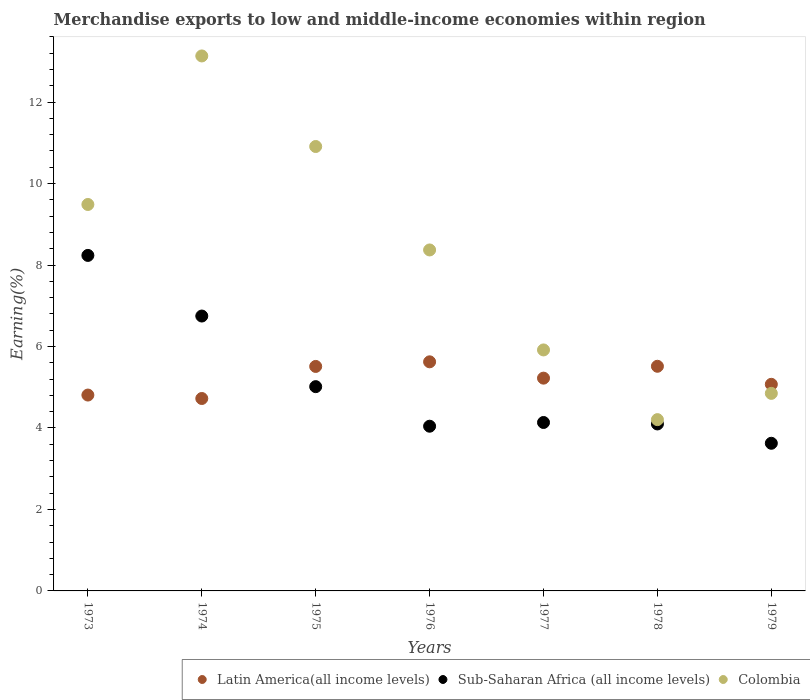What is the percentage of amount earned from merchandise exports in Sub-Saharan Africa (all income levels) in 1973?
Give a very brief answer. 8.24. Across all years, what is the maximum percentage of amount earned from merchandise exports in Latin America(all income levels)?
Your answer should be compact. 5.62. Across all years, what is the minimum percentage of amount earned from merchandise exports in Sub-Saharan Africa (all income levels)?
Your answer should be very brief. 3.62. In which year was the percentage of amount earned from merchandise exports in Colombia maximum?
Ensure brevity in your answer.  1974. In which year was the percentage of amount earned from merchandise exports in Colombia minimum?
Provide a succinct answer. 1978. What is the total percentage of amount earned from merchandise exports in Sub-Saharan Africa (all income levels) in the graph?
Provide a succinct answer. 35.9. What is the difference between the percentage of amount earned from merchandise exports in Sub-Saharan Africa (all income levels) in 1973 and that in 1975?
Offer a terse response. 3.22. What is the difference between the percentage of amount earned from merchandise exports in Sub-Saharan Africa (all income levels) in 1979 and the percentage of amount earned from merchandise exports in Latin America(all income levels) in 1975?
Offer a terse response. -1.89. What is the average percentage of amount earned from merchandise exports in Colombia per year?
Give a very brief answer. 8.12. In the year 1973, what is the difference between the percentage of amount earned from merchandise exports in Sub-Saharan Africa (all income levels) and percentage of amount earned from merchandise exports in Latin America(all income levels)?
Your response must be concise. 3.43. What is the ratio of the percentage of amount earned from merchandise exports in Latin America(all income levels) in 1976 to that in 1977?
Your answer should be compact. 1.08. Is the percentage of amount earned from merchandise exports in Colombia in 1973 less than that in 1977?
Offer a very short reply. No. Is the difference between the percentage of amount earned from merchandise exports in Sub-Saharan Africa (all income levels) in 1975 and 1978 greater than the difference between the percentage of amount earned from merchandise exports in Latin America(all income levels) in 1975 and 1978?
Make the answer very short. Yes. What is the difference between the highest and the second highest percentage of amount earned from merchandise exports in Latin America(all income levels)?
Offer a very short reply. 0.11. What is the difference between the highest and the lowest percentage of amount earned from merchandise exports in Latin America(all income levels)?
Your answer should be very brief. 0.9. Is the sum of the percentage of amount earned from merchandise exports in Latin America(all income levels) in 1973 and 1978 greater than the maximum percentage of amount earned from merchandise exports in Colombia across all years?
Your response must be concise. No. Does the percentage of amount earned from merchandise exports in Latin America(all income levels) monotonically increase over the years?
Offer a very short reply. No. Is the percentage of amount earned from merchandise exports in Sub-Saharan Africa (all income levels) strictly greater than the percentage of amount earned from merchandise exports in Latin America(all income levels) over the years?
Ensure brevity in your answer.  No. How many dotlines are there?
Your answer should be compact. 3. What is the title of the graph?
Keep it short and to the point. Merchandise exports to low and middle-income economies within region. Does "Italy" appear as one of the legend labels in the graph?
Your response must be concise. No. What is the label or title of the X-axis?
Provide a succinct answer. Years. What is the label or title of the Y-axis?
Make the answer very short. Earning(%). What is the Earning(%) of Latin America(all income levels) in 1973?
Make the answer very short. 4.81. What is the Earning(%) of Sub-Saharan Africa (all income levels) in 1973?
Offer a very short reply. 8.24. What is the Earning(%) of Colombia in 1973?
Your answer should be very brief. 9.49. What is the Earning(%) of Latin America(all income levels) in 1974?
Provide a succinct answer. 4.72. What is the Earning(%) of Sub-Saharan Africa (all income levels) in 1974?
Offer a very short reply. 6.75. What is the Earning(%) of Colombia in 1974?
Provide a succinct answer. 13.13. What is the Earning(%) of Latin America(all income levels) in 1975?
Your answer should be very brief. 5.51. What is the Earning(%) of Sub-Saharan Africa (all income levels) in 1975?
Keep it short and to the point. 5.01. What is the Earning(%) in Colombia in 1975?
Your answer should be compact. 10.91. What is the Earning(%) of Latin America(all income levels) in 1976?
Ensure brevity in your answer.  5.62. What is the Earning(%) of Sub-Saharan Africa (all income levels) in 1976?
Give a very brief answer. 4.04. What is the Earning(%) of Colombia in 1976?
Offer a very short reply. 8.37. What is the Earning(%) of Latin America(all income levels) in 1977?
Ensure brevity in your answer.  5.22. What is the Earning(%) in Sub-Saharan Africa (all income levels) in 1977?
Keep it short and to the point. 4.13. What is the Earning(%) in Colombia in 1977?
Give a very brief answer. 5.92. What is the Earning(%) of Latin America(all income levels) in 1978?
Keep it short and to the point. 5.51. What is the Earning(%) in Sub-Saharan Africa (all income levels) in 1978?
Your response must be concise. 4.1. What is the Earning(%) in Colombia in 1978?
Keep it short and to the point. 4.2. What is the Earning(%) in Latin America(all income levels) in 1979?
Give a very brief answer. 5.07. What is the Earning(%) in Sub-Saharan Africa (all income levels) in 1979?
Make the answer very short. 3.62. What is the Earning(%) of Colombia in 1979?
Your response must be concise. 4.85. Across all years, what is the maximum Earning(%) of Latin America(all income levels)?
Ensure brevity in your answer.  5.62. Across all years, what is the maximum Earning(%) in Sub-Saharan Africa (all income levels)?
Keep it short and to the point. 8.24. Across all years, what is the maximum Earning(%) of Colombia?
Your answer should be very brief. 13.13. Across all years, what is the minimum Earning(%) of Latin America(all income levels)?
Your answer should be compact. 4.72. Across all years, what is the minimum Earning(%) of Sub-Saharan Africa (all income levels)?
Offer a very short reply. 3.62. Across all years, what is the minimum Earning(%) of Colombia?
Make the answer very short. 4.2. What is the total Earning(%) in Latin America(all income levels) in the graph?
Your answer should be compact. 36.47. What is the total Earning(%) of Sub-Saharan Africa (all income levels) in the graph?
Offer a very short reply. 35.9. What is the total Earning(%) of Colombia in the graph?
Make the answer very short. 56.87. What is the difference between the Earning(%) in Latin America(all income levels) in 1973 and that in 1974?
Your answer should be very brief. 0.08. What is the difference between the Earning(%) of Sub-Saharan Africa (all income levels) in 1973 and that in 1974?
Offer a very short reply. 1.49. What is the difference between the Earning(%) of Colombia in 1973 and that in 1974?
Offer a terse response. -3.65. What is the difference between the Earning(%) in Latin America(all income levels) in 1973 and that in 1975?
Your response must be concise. -0.7. What is the difference between the Earning(%) in Sub-Saharan Africa (all income levels) in 1973 and that in 1975?
Keep it short and to the point. 3.22. What is the difference between the Earning(%) in Colombia in 1973 and that in 1975?
Keep it short and to the point. -1.42. What is the difference between the Earning(%) in Latin America(all income levels) in 1973 and that in 1976?
Provide a succinct answer. -0.82. What is the difference between the Earning(%) of Sub-Saharan Africa (all income levels) in 1973 and that in 1976?
Offer a terse response. 4.19. What is the difference between the Earning(%) of Colombia in 1973 and that in 1976?
Ensure brevity in your answer.  1.12. What is the difference between the Earning(%) in Latin America(all income levels) in 1973 and that in 1977?
Your response must be concise. -0.41. What is the difference between the Earning(%) of Sub-Saharan Africa (all income levels) in 1973 and that in 1977?
Your answer should be very brief. 4.1. What is the difference between the Earning(%) of Colombia in 1973 and that in 1977?
Keep it short and to the point. 3.57. What is the difference between the Earning(%) in Latin America(all income levels) in 1973 and that in 1978?
Give a very brief answer. -0.71. What is the difference between the Earning(%) in Sub-Saharan Africa (all income levels) in 1973 and that in 1978?
Your answer should be compact. 4.14. What is the difference between the Earning(%) in Colombia in 1973 and that in 1978?
Your answer should be compact. 5.28. What is the difference between the Earning(%) of Latin America(all income levels) in 1973 and that in 1979?
Offer a very short reply. -0.26. What is the difference between the Earning(%) in Sub-Saharan Africa (all income levels) in 1973 and that in 1979?
Make the answer very short. 4.61. What is the difference between the Earning(%) in Colombia in 1973 and that in 1979?
Offer a very short reply. 4.64. What is the difference between the Earning(%) in Latin America(all income levels) in 1974 and that in 1975?
Make the answer very short. -0.79. What is the difference between the Earning(%) in Sub-Saharan Africa (all income levels) in 1974 and that in 1975?
Keep it short and to the point. 1.73. What is the difference between the Earning(%) of Colombia in 1974 and that in 1975?
Your answer should be compact. 2.22. What is the difference between the Earning(%) in Latin America(all income levels) in 1974 and that in 1976?
Ensure brevity in your answer.  -0.9. What is the difference between the Earning(%) in Sub-Saharan Africa (all income levels) in 1974 and that in 1976?
Keep it short and to the point. 2.7. What is the difference between the Earning(%) in Colombia in 1974 and that in 1976?
Give a very brief answer. 4.76. What is the difference between the Earning(%) of Latin America(all income levels) in 1974 and that in 1977?
Your answer should be very brief. -0.5. What is the difference between the Earning(%) in Sub-Saharan Africa (all income levels) in 1974 and that in 1977?
Provide a succinct answer. 2.61. What is the difference between the Earning(%) in Colombia in 1974 and that in 1977?
Make the answer very short. 7.22. What is the difference between the Earning(%) in Latin America(all income levels) in 1974 and that in 1978?
Offer a very short reply. -0.79. What is the difference between the Earning(%) of Sub-Saharan Africa (all income levels) in 1974 and that in 1978?
Provide a succinct answer. 2.65. What is the difference between the Earning(%) in Colombia in 1974 and that in 1978?
Your response must be concise. 8.93. What is the difference between the Earning(%) of Latin America(all income levels) in 1974 and that in 1979?
Keep it short and to the point. -0.35. What is the difference between the Earning(%) in Sub-Saharan Africa (all income levels) in 1974 and that in 1979?
Ensure brevity in your answer.  3.12. What is the difference between the Earning(%) of Colombia in 1974 and that in 1979?
Provide a succinct answer. 8.28. What is the difference between the Earning(%) in Latin America(all income levels) in 1975 and that in 1976?
Make the answer very short. -0.11. What is the difference between the Earning(%) in Sub-Saharan Africa (all income levels) in 1975 and that in 1976?
Provide a short and direct response. 0.97. What is the difference between the Earning(%) in Colombia in 1975 and that in 1976?
Provide a short and direct response. 2.54. What is the difference between the Earning(%) of Latin America(all income levels) in 1975 and that in 1977?
Provide a succinct answer. 0.29. What is the difference between the Earning(%) in Sub-Saharan Africa (all income levels) in 1975 and that in 1977?
Keep it short and to the point. 0.88. What is the difference between the Earning(%) of Colombia in 1975 and that in 1977?
Your answer should be very brief. 4.99. What is the difference between the Earning(%) of Latin America(all income levels) in 1975 and that in 1978?
Give a very brief answer. -0. What is the difference between the Earning(%) of Sub-Saharan Africa (all income levels) in 1975 and that in 1978?
Offer a terse response. 0.92. What is the difference between the Earning(%) of Colombia in 1975 and that in 1978?
Provide a short and direct response. 6.7. What is the difference between the Earning(%) of Latin America(all income levels) in 1975 and that in 1979?
Your answer should be compact. 0.44. What is the difference between the Earning(%) in Sub-Saharan Africa (all income levels) in 1975 and that in 1979?
Make the answer very short. 1.39. What is the difference between the Earning(%) in Colombia in 1975 and that in 1979?
Your answer should be very brief. 6.06. What is the difference between the Earning(%) in Latin America(all income levels) in 1976 and that in 1977?
Your response must be concise. 0.4. What is the difference between the Earning(%) in Sub-Saharan Africa (all income levels) in 1976 and that in 1977?
Your answer should be compact. -0.09. What is the difference between the Earning(%) in Colombia in 1976 and that in 1977?
Your answer should be very brief. 2.45. What is the difference between the Earning(%) in Latin America(all income levels) in 1976 and that in 1978?
Offer a very short reply. 0.11. What is the difference between the Earning(%) in Sub-Saharan Africa (all income levels) in 1976 and that in 1978?
Make the answer very short. -0.06. What is the difference between the Earning(%) of Colombia in 1976 and that in 1978?
Offer a terse response. 4.17. What is the difference between the Earning(%) of Latin America(all income levels) in 1976 and that in 1979?
Your answer should be compact. 0.55. What is the difference between the Earning(%) in Sub-Saharan Africa (all income levels) in 1976 and that in 1979?
Make the answer very short. 0.42. What is the difference between the Earning(%) of Colombia in 1976 and that in 1979?
Provide a short and direct response. 3.52. What is the difference between the Earning(%) in Latin America(all income levels) in 1977 and that in 1978?
Offer a terse response. -0.29. What is the difference between the Earning(%) in Sub-Saharan Africa (all income levels) in 1977 and that in 1978?
Provide a succinct answer. 0.04. What is the difference between the Earning(%) in Colombia in 1977 and that in 1978?
Provide a short and direct response. 1.71. What is the difference between the Earning(%) in Latin America(all income levels) in 1977 and that in 1979?
Give a very brief answer. 0.15. What is the difference between the Earning(%) of Sub-Saharan Africa (all income levels) in 1977 and that in 1979?
Your answer should be compact. 0.51. What is the difference between the Earning(%) of Colombia in 1977 and that in 1979?
Your answer should be compact. 1.07. What is the difference between the Earning(%) in Latin America(all income levels) in 1978 and that in 1979?
Provide a short and direct response. 0.44. What is the difference between the Earning(%) in Sub-Saharan Africa (all income levels) in 1978 and that in 1979?
Give a very brief answer. 0.47. What is the difference between the Earning(%) in Colombia in 1978 and that in 1979?
Your answer should be very brief. -0.64. What is the difference between the Earning(%) of Latin America(all income levels) in 1973 and the Earning(%) of Sub-Saharan Africa (all income levels) in 1974?
Provide a short and direct response. -1.94. What is the difference between the Earning(%) of Latin America(all income levels) in 1973 and the Earning(%) of Colombia in 1974?
Your answer should be compact. -8.32. What is the difference between the Earning(%) in Sub-Saharan Africa (all income levels) in 1973 and the Earning(%) in Colombia in 1974?
Give a very brief answer. -4.9. What is the difference between the Earning(%) of Latin America(all income levels) in 1973 and the Earning(%) of Sub-Saharan Africa (all income levels) in 1975?
Offer a very short reply. -0.21. What is the difference between the Earning(%) of Latin America(all income levels) in 1973 and the Earning(%) of Colombia in 1975?
Ensure brevity in your answer.  -6.1. What is the difference between the Earning(%) of Sub-Saharan Africa (all income levels) in 1973 and the Earning(%) of Colombia in 1975?
Provide a short and direct response. -2.67. What is the difference between the Earning(%) in Latin America(all income levels) in 1973 and the Earning(%) in Sub-Saharan Africa (all income levels) in 1976?
Make the answer very short. 0.77. What is the difference between the Earning(%) of Latin America(all income levels) in 1973 and the Earning(%) of Colombia in 1976?
Offer a terse response. -3.56. What is the difference between the Earning(%) of Sub-Saharan Africa (all income levels) in 1973 and the Earning(%) of Colombia in 1976?
Your response must be concise. -0.13. What is the difference between the Earning(%) of Latin America(all income levels) in 1973 and the Earning(%) of Sub-Saharan Africa (all income levels) in 1977?
Your answer should be very brief. 0.67. What is the difference between the Earning(%) in Latin America(all income levels) in 1973 and the Earning(%) in Colombia in 1977?
Give a very brief answer. -1.11. What is the difference between the Earning(%) of Sub-Saharan Africa (all income levels) in 1973 and the Earning(%) of Colombia in 1977?
Keep it short and to the point. 2.32. What is the difference between the Earning(%) in Latin America(all income levels) in 1973 and the Earning(%) in Sub-Saharan Africa (all income levels) in 1978?
Your answer should be very brief. 0.71. What is the difference between the Earning(%) of Latin America(all income levels) in 1973 and the Earning(%) of Colombia in 1978?
Keep it short and to the point. 0.6. What is the difference between the Earning(%) of Sub-Saharan Africa (all income levels) in 1973 and the Earning(%) of Colombia in 1978?
Make the answer very short. 4.03. What is the difference between the Earning(%) in Latin America(all income levels) in 1973 and the Earning(%) in Sub-Saharan Africa (all income levels) in 1979?
Give a very brief answer. 1.18. What is the difference between the Earning(%) in Latin America(all income levels) in 1973 and the Earning(%) in Colombia in 1979?
Offer a very short reply. -0.04. What is the difference between the Earning(%) in Sub-Saharan Africa (all income levels) in 1973 and the Earning(%) in Colombia in 1979?
Your response must be concise. 3.39. What is the difference between the Earning(%) in Latin America(all income levels) in 1974 and the Earning(%) in Sub-Saharan Africa (all income levels) in 1975?
Provide a short and direct response. -0.29. What is the difference between the Earning(%) of Latin America(all income levels) in 1974 and the Earning(%) of Colombia in 1975?
Your answer should be very brief. -6.19. What is the difference between the Earning(%) of Sub-Saharan Africa (all income levels) in 1974 and the Earning(%) of Colombia in 1975?
Offer a very short reply. -4.16. What is the difference between the Earning(%) of Latin America(all income levels) in 1974 and the Earning(%) of Sub-Saharan Africa (all income levels) in 1976?
Your response must be concise. 0.68. What is the difference between the Earning(%) of Latin America(all income levels) in 1974 and the Earning(%) of Colombia in 1976?
Ensure brevity in your answer.  -3.65. What is the difference between the Earning(%) in Sub-Saharan Africa (all income levels) in 1974 and the Earning(%) in Colombia in 1976?
Your answer should be very brief. -1.62. What is the difference between the Earning(%) of Latin America(all income levels) in 1974 and the Earning(%) of Sub-Saharan Africa (all income levels) in 1977?
Make the answer very short. 0.59. What is the difference between the Earning(%) of Latin America(all income levels) in 1974 and the Earning(%) of Colombia in 1977?
Ensure brevity in your answer.  -1.19. What is the difference between the Earning(%) in Sub-Saharan Africa (all income levels) in 1974 and the Earning(%) in Colombia in 1977?
Provide a short and direct response. 0.83. What is the difference between the Earning(%) in Latin America(all income levels) in 1974 and the Earning(%) in Sub-Saharan Africa (all income levels) in 1978?
Provide a short and direct response. 0.62. What is the difference between the Earning(%) of Latin America(all income levels) in 1974 and the Earning(%) of Colombia in 1978?
Provide a succinct answer. 0.52. What is the difference between the Earning(%) in Sub-Saharan Africa (all income levels) in 1974 and the Earning(%) in Colombia in 1978?
Ensure brevity in your answer.  2.54. What is the difference between the Earning(%) of Latin America(all income levels) in 1974 and the Earning(%) of Sub-Saharan Africa (all income levels) in 1979?
Your answer should be very brief. 1.1. What is the difference between the Earning(%) of Latin America(all income levels) in 1974 and the Earning(%) of Colombia in 1979?
Your answer should be compact. -0.13. What is the difference between the Earning(%) in Sub-Saharan Africa (all income levels) in 1974 and the Earning(%) in Colombia in 1979?
Ensure brevity in your answer.  1.9. What is the difference between the Earning(%) in Latin America(all income levels) in 1975 and the Earning(%) in Sub-Saharan Africa (all income levels) in 1976?
Offer a terse response. 1.47. What is the difference between the Earning(%) of Latin America(all income levels) in 1975 and the Earning(%) of Colombia in 1976?
Give a very brief answer. -2.86. What is the difference between the Earning(%) in Sub-Saharan Africa (all income levels) in 1975 and the Earning(%) in Colombia in 1976?
Keep it short and to the point. -3.36. What is the difference between the Earning(%) in Latin America(all income levels) in 1975 and the Earning(%) in Sub-Saharan Africa (all income levels) in 1977?
Provide a succinct answer. 1.38. What is the difference between the Earning(%) of Latin America(all income levels) in 1975 and the Earning(%) of Colombia in 1977?
Give a very brief answer. -0.41. What is the difference between the Earning(%) in Sub-Saharan Africa (all income levels) in 1975 and the Earning(%) in Colombia in 1977?
Your answer should be very brief. -0.9. What is the difference between the Earning(%) in Latin America(all income levels) in 1975 and the Earning(%) in Sub-Saharan Africa (all income levels) in 1978?
Your response must be concise. 1.41. What is the difference between the Earning(%) in Latin America(all income levels) in 1975 and the Earning(%) in Colombia in 1978?
Make the answer very short. 1.31. What is the difference between the Earning(%) of Sub-Saharan Africa (all income levels) in 1975 and the Earning(%) of Colombia in 1978?
Your response must be concise. 0.81. What is the difference between the Earning(%) of Latin America(all income levels) in 1975 and the Earning(%) of Sub-Saharan Africa (all income levels) in 1979?
Provide a succinct answer. 1.89. What is the difference between the Earning(%) of Latin America(all income levels) in 1975 and the Earning(%) of Colombia in 1979?
Keep it short and to the point. 0.66. What is the difference between the Earning(%) in Sub-Saharan Africa (all income levels) in 1975 and the Earning(%) in Colombia in 1979?
Provide a short and direct response. 0.17. What is the difference between the Earning(%) in Latin America(all income levels) in 1976 and the Earning(%) in Sub-Saharan Africa (all income levels) in 1977?
Give a very brief answer. 1.49. What is the difference between the Earning(%) of Latin America(all income levels) in 1976 and the Earning(%) of Colombia in 1977?
Your response must be concise. -0.29. What is the difference between the Earning(%) of Sub-Saharan Africa (all income levels) in 1976 and the Earning(%) of Colombia in 1977?
Your answer should be compact. -1.87. What is the difference between the Earning(%) of Latin America(all income levels) in 1976 and the Earning(%) of Sub-Saharan Africa (all income levels) in 1978?
Your answer should be very brief. 1.52. What is the difference between the Earning(%) in Latin America(all income levels) in 1976 and the Earning(%) in Colombia in 1978?
Make the answer very short. 1.42. What is the difference between the Earning(%) of Sub-Saharan Africa (all income levels) in 1976 and the Earning(%) of Colombia in 1978?
Give a very brief answer. -0.16. What is the difference between the Earning(%) in Latin America(all income levels) in 1976 and the Earning(%) in Sub-Saharan Africa (all income levels) in 1979?
Your answer should be very brief. 2. What is the difference between the Earning(%) in Latin America(all income levels) in 1976 and the Earning(%) in Colombia in 1979?
Provide a succinct answer. 0.77. What is the difference between the Earning(%) in Sub-Saharan Africa (all income levels) in 1976 and the Earning(%) in Colombia in 1979?
Offer a very short reply. -0.81. What is the difference between the Earning(%) in Latin America(all income levels) in 1977 and the Earning(%) in Sub-Saharan Africa (all income levels) in 1978?
Make the answer very short. 1.12. What is the difference between the Earning(%) in Latin America(all income levels) in 1977 and the Earning(%) in Colombia in 1978?
Provide a short and direct response. 1.02. What is the difference between the Earning(%) in Sub-Saharan Africa (all income levels) in 1977 and the Earning(%) in Colombia in 1978?
Your answer should be very brief. -0.07. What is the difference between the Earning(%) of Latin America(all income levels) in 1977 and the Earning(%) of Sub-Saharan Africa (all income levels) in 1979?
Provide a short and direct response. 1.6. What is the difference between the Earning(%) in Latin America(all income levels) in 1977 and the Earning(%) in Colombia in 1979?
Provide a succinct answer. 0.37. What is the difference between the Earning(%) of Sub-Saharan Africa (all income levels) in 1977 and the Earning(%) of Colombia in 1979?
Provide a short and direct response. -0.71. What is the difference between the Earning(%) of Latin America(all income levels) in 1978 and the Earning(%) of Sub-Saharan Africa (all income levels) in 1979?
Provide a short and direct response. 1.89. What is the difference between the Earning(%) in Latin America(all income levels) in 1978 and the Earning(%) in Colombia in 1979?
Provide a short and direct response. 0.67. What is the difference between the Earning(%) of Sub-Saharan Africa (all income levels) in 1978 and the Earning(%) of Colombia in 1979?
Provide a short and direct response. -0.75. What is the average Earning(%) of Latin America(all income levels) per year?
Provide a succinct answer. 5.21. What is the average Earning(%) of Sub-Saharan Africa (all income levels) per year?
Provide a succinct answer. 5.13. What is the average Earning(%) in Colombia per year?
Provide a short and direct response. 8.12. In the year 1973, what is the difference between the Earning(%) of Latin America(all income levels) and Earning(%) of Sub-Saharan Africa (all income levels)?
Keep it short and to the point. -3.43. In the year 1973, what is the difference between the Earning(%) in Latin America(all income levels) and Earning(%) in Colombia?
Your answer should be very brief. -4.68. In the year 1973, what is the difference between the Earning(%) in Sub-Saharan Africa (all income levels) and Earning(%) in Colombia?
Your answer should be very brief. -1.25. In the year 1974, what is the difference between the Earning(%) of Latin America(all income levels) and Earning(%) of Sub-Saharan Africa (all income levels)?
Offer a very short reply. -2.02. In the year 1974, what is the difference between the Earning(%) of Latin America(all income levels) and Earning(%) of Colombia?
Offer a terse response. -8.41. In the year 1974, what is the difference between the Earning(%) in Sub-Saharan Africa (all income levels) and Earning(%) in Colombia?
Provide a succinct answer. -6.38. In the year 1975, what is the difference between the Earning(%) of Latin America(all income levels) and Earning(%) of Sub-Saharan Africa (all income levels)?
Provide a succinct answer. 0.5. In the year 1975, what is the difference between the Earning(%) in Latin America(all income levels) and Earning(%) in Colombia?
Your response must be concise. -5.4. In the year 1975, what is the difference between the Earning(%) of Sub-Saharan Africa (all income levels) and Earning(%) of Colombia?
Provide a succinct answer. -5.89. In the year 1976, what is the difference between the Earning(%) of Latin America(all income levels) and Earning(%) of Sub-Saharan Africa (all income levels)?
Provide a short and direct response. 1.58. In the year 1976, what is the difference between the Earning(%) of Latin America(all income levels) and Earning(%) of Colombia?
Ensure brevity in your answer.  -2.75. In the year 1976, what is the difference between the Earning(%) of Sub-Saharan Africa (all income levels) and Earning(%) of Colombia?
Provide a short and direct response. -4.33. In the year 1977, what is the difference between the Earning(%) in Latin America(all income levels) and Earning(%) in Sub-Saharan Africa (all income levels)?
Make the answer very short. 1.09. In the year 1977, what is the difference between the Earning(%) in Latin America(all income levels) and Earning(%) in Colombia?
Provide a short and direct response. -0.69. In the year 1977, what is the difference between the Earning(%) of Sub-Saharan Africa (all income levels) and Earning(%) of Colombia?
Provide a succinct answer. -1.78. In the year 1978, what is the difference between the Earning(%) of Latin America(all income levels) and Earning(%) of Sub-Saharan Africa (all income levels)?
Provide a succinct answer. 1.42. In the year 1978, what is the difference between the Earning(%) in Latin America(all income levels) and Earning(%) in Colombia?
Make the answer very short. 1.31. In the year 1978, what is the difference between the Earning(%) in Sub-Saharan Africa (all income levels) and Earning(%) in Colombia?
Provide a succinct answer. -0.11. In the year 1979, what is the difference between the Earning(%) of Latin America(all income levels) and Earning(%) of Sub-Saharan Africa (all income levels)?
Provide a succinct answer. 1.45. In the year 1979, what is the difference between the Earning(%) of Latin America(all income levels) and Earning(%) of Colombia?
Your response must be concise. 0.22. In the year 1979, what is the difference between the Earning(%) of Sub-Saharan Africa (all income levels) and Earning(%) of Colombia?
Provide a succinct answer. -1.23. What is the ratio of the Earning(%) of Latin America(all income levels) in 1973 to that in 1974?
Offer a very short reply. 1.02. What is the ratio of the Earning(%) in Sub-Saharan Africa (all income levels) in 1973 to that in 1974?
Keep it short and to the point. 1.22. What is the ratio of the Earning(%) in Colombia in 1973 to that in 1974?
Give a very brief answer. 0.72. What is the ratio of the Earning(%) in Latin America(all income levels) in 1973 to that in 1975?
Offer a terse response. 0.87. What is the ratio of the Earning(%) in Sub-Saharan Africa (all income levels) in 1973 to that in 1975?
Your answer should be compact. 1.64. What is the ratio of the Earning(%) in Colombia in 1973 to that in 1975?
Keep it short and to the point. 0.87. What is the ratio of the Earning(%) of Latin America(all income levels) in 1973 to that in 1976?
Provide a short and direct response. 0.85. What is the ratio of the Earning(%) in Sub-Saharan Africa (all income levels) in 1973 to that in 1976?
Your answer should be very brief. 2.04. What is the ratio of the Earning(%) in Colombia in 1973 to that in 1976?
Offer a terse response. 1.13. What is the ratio of the Earning(%) of Latin America(all income levels) in 1973 to that in 1977?
Give a very brief answer. 0.92. What is the ratio of the Earning(%) in Sub-Saharan Africa (all income levels) in 1973 to that in 1977?
Give a very brief answer. 1.99. What is the ratio of the Earning(%) of Colombia in 1973 to that in 1977?
Make the answer very short. 1.6. What is the ratio of the Earning(%) of Latin America(all income levels) in 1973 to that in 1978?
Your response must be concise. 0.87. What is the ratio of the Earning(%) of Sub-Saharan Africa (all income levels) in 1973 to that in 1978?
Your answer should be compact. 2.01. What is the ratio of the Earning(%) in Colombia in 1973 to that in 1978?
Offer a terse response. 2.26. What is the ratio of the Earning(%) of Latin America(all income levels) in 1973 to that in 1979?
Your answer should be very brief. 0.95. What is the ratio of the Earning(%) of Sub-Saharan Africa (all income levels) in 1973 to that in 1979?
Make the answer very short. 2.27. What is the ratio of the Earning(%) of Colombia in 1973 to that in 1979?
Offer a very short reply. 1.96. What is the ratio of the Earning(%) of Latin America(all income levels) in 1974 to that in 1975?
Offer a terse response. 0.86. What is the ratio of the Earning(%) of Sub-Saharan Africa (all income levels) in 1974 to that in 1975?
Provide a short and direct response. 1.35. What is the ratio of the Earning(%) of Colombia in 1974 to that in 1975?
Ensure brevity in your answer.  1.2. What is the ratio of the Earning(%) of Latin America(all income levels) in 1974 to that in 1976?
Provide a short and direct response. 0.84. What is the ratio of the Earning(%) in Sub-Saharan Africa (all income levels) in 1974 to that in 1976?
Offer a terse response. 1.67. What is the ratio of the Earning(%) of Colombia in 1974 to that in 1976?
Provide a succinct answer. 1.57. What is the ratio of the Earning(%) in Latin America(all income levels) in 1974 to that in 1977?
Make the answer very short. 0.9. What is the ratio of the Earning(%) of Sub-Saharan Africa (all income levels) in 1974 to that in 1977?
Your answer should be very brief. 1.63. What is the ratio of the Earning(%) in Colombia in 1974 to that in 1977?
Ensure brevity in your answer.  2.22. What is the ratio of the Earning(%) of Latin America(all income levels) in 1974 to that in 1978?
Provide a short and direct response. 0.86. What is the ratio of the Earning(%) of Sub-Saharan Africa (all income levels) in 1974 to that in 1978?
Keep it short and to the point. 1.65. What is the ratio of the Earning(%) in Colombia in 1974 to that in 1978?
Keep it short and to the point. 3.12. What is the ratio of the Earning(%) of Latin America(all income levels) in 1974 to that in 1979?
Offer a terse response. 0.93. What is the ratio of the Earning(%) of Sub-Saharan Africa (all income levels) in 1974 to that in 1979?
Provide a succinct answer. 1.86. What is the ratio of the Earning(%) in Colombia in 1974 to that in 1979?
Your answer should be compact. 2.71. What is the ratio of the Earning(%) of Latin America(all income levels) in 1975 to that in 1976?
Provide a succinct answer. 0.98. What is the ratio of the Earning(%) of Sub-Saharan Africa (all income levels) in 1975 to that in 1976?
Offer a terse response. 1.24. What is the ratio of the Earning(%) of Colombia in 1975 to that in 1976?
Provide a short and direct response. 1.3. What is the ratio of the Earning(%) in Latin America(all income levels) in 1975 to that in 1977?
Your answer should be compact. 1.05. What is the ratio of the Earning(%) in Sub-Saharan Africa (all income levels) in 1975 to that in 1977?
Offer a terse response. 1.21. What is the ratio of the Earning(%) of Colombia in 1975 to that in 1977?
Offer a terse response. 1.84. What is the ratio of the Earning(%) in Sub-Saharan Africa (all income levels) in 1975 to that in 1978?
Provide a succinct answer. 1.22. What is the ratio of the Earning(%) of Colombia in 1975 to that in 1978?
Provide a short and direct response. 2.59. What is the ratio of the Earning(%) of Latin America(all income levels) in 1975 to that in 1979?
Make the answer very short. 1.09. What is the ratio of the Earning(%) of Sub-Saharan Africa (all income levels) in 1975 to that in 1979?
Provide a short and direct response. 1.38. What is the ratio of the Earning(%) of Colombia in 1975 to that in 1979?
Ensure brevity in your answer.  2.25. What is the ratio of the Earning(%) of Latin America(all income levels) in 1976 to that in 1977?
Ensure brevity in your answer.  1.08. What is the ratio of the Earning(%) of Sub-Saharan Africa (all income levels) in 1976 to that in 1977?
Your response must be concise. 0.98. What is the ratio of the Earning(%) of Colombia in 1976 to that in 1977?
Offer a very short reply. 1.41. What is the ratio of the Earning(%) of Latin America(all income levels) in 1976 to that in 1978?
Your answer should be very brief. 1.02. What is the ratio of the Earning(%) of Sub-Saharan Africa (all income levels) in 1976 to that in 1978?
Your answer should be very brief. 0.99. What is the ratio of the Earning(%) in Colombia in 1976 to that in 1978?
Provide a succinct answer. 1.99. What is the ratio of the Earning(%) in Latin America(all income levels) in 1976 to that in 1979?
Offer a terse response. 1.11. What is the ratio of the Earning(%) in Sub-Saharan Africa (all income levels) in 1976 to that in 1979?
Your answer should be very brief. 1.12. What is the ratio of the Earning(%) of Colombia in 1976 to that in 1979?
Your response must be concise. 1.73. What is the ratio of the Earning(%) of Latin America(all income levels) in 1977 to that in 1978?
Your answer should be very brief. 0.95. What is the ratio of the Earning(%) in Sub-Saharan Africa (all income levels) in 1977 to that in 1978?
Make the answer very short. 1.01. What is the ratio of the Earning(%) of Colombia in 1977 to that in 1978?
Keep it short and to the point. 1.41. What is the ratio of the Earning(%) of Latin America(all income levels) in 1977 to that in 1979?
Provide a succinct answer. 1.03. What is the ratio of the Earning(%) of Sub-Saharan Africa (all income levels) in 1977 to that in 1979?
Keep it short and to the point. 1.14. What is the ratio of the Earning(%) of Colombia in 1977 to that in 1979?
Your answer should be compact. 1.22. What is the ratio of the Earning(%) in Latin America(all income levels) in 1978 to that in 1979?
Keep it short and to the point. 1.09. What is the ratio of the Earning(%) in Sub-Saharan Africa (all income levels) in 1978 to that in 1979?
Ensure brevity in your answer.  1.13. What is the ratio of the Earning(%) of Colombia in 1978 to that in 1979?
Give a very brief answer. 0.87. What is the difference between the highest and the second highest Earning(%) in Latin America(all income levels)?
Your response must be concise. 0.11. What is the difference between the highest and the second highest Earning(%) of Sub-Saharan Africa (all income levels)?
Provide a short and direct response. 1.49. What is the difference between the highest and the second highest Earning(%) in Colombia?
Ensure brevity in your answer.  2.22. What is the difference between the highest and the lowest Earning(%) of Latin America(all income levels)?
Keep it short and to the point. 0.9. What is the difference between the highest and the lowest Earning(%) in Sub-Saharan Africa (all income levels)?
Offer a very short reply. 4.61. What is the difference between the highest and the lowest Earning(%) in Colombia?
Keep it short and to the point. 8.93. 